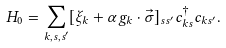<formula> <loc_0><loc_0><loc_500><loc_500>H _ { 0 } = \sum _ { k , s , s ^ { \prime } } [ \xi _ { k } + \alpha g _ { k } \cdot \vec { \sigma } ] _ { s s ^ { \prime } } c _ { k s } ^ { \dagger } c _ { k s ^ { \prime } } .</formula> 